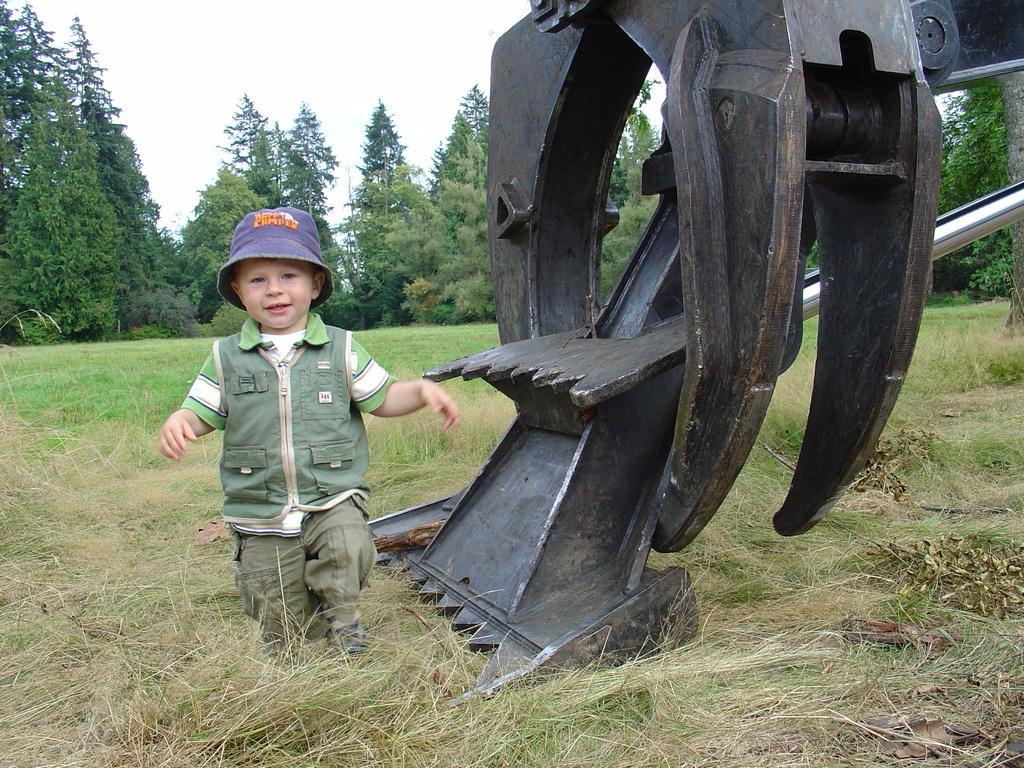How would you summarize this image in a sentence or two? In this image there is a kid walking on the ground. Beside him there is a crane. In the background there are trees. At the bottom there is grass. 